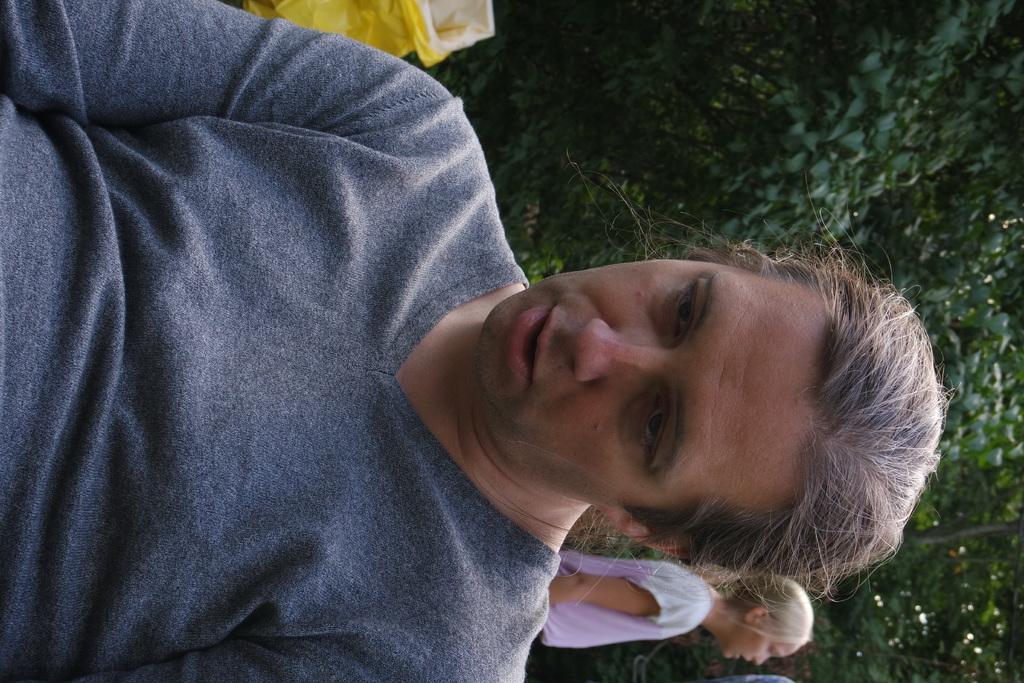Can you describe this image briefly? This is a tilted image in this image there is a person sitting on a chair, in the background there are people standing and there are trees and there is a bag. 